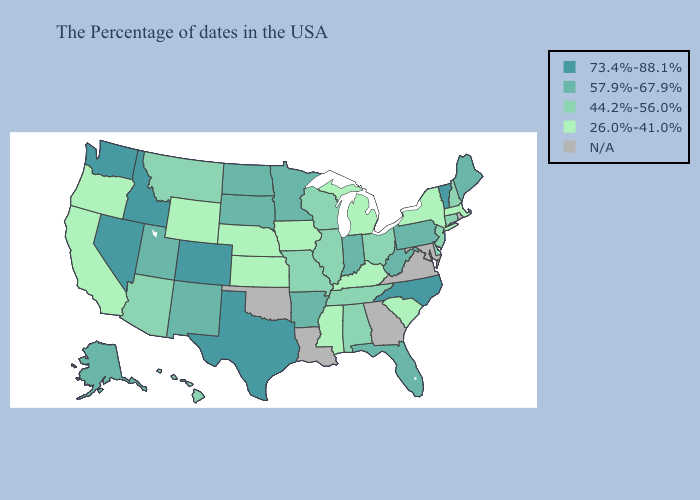Does the first symbol in the legend represent the smallest category?
Concise answer only. No. What is the lowest value in states that border Nebraska?
Give a very brief answer. 26.0%-41.0%. Does West Virginia have the highest value in the USA?
Keep it brief. No. Among the states that border Alabama , does Mississippi have the lowest value?
Concise answer only. Yes. Which states have the lowest value in the South?
Quick response, please. South Carolina, Kentucky, Mississippi. Which states have the highest value in the USA?
Write a very short answer. Vermont, North Carolina, Texas, Colorado, Idaho, Nevada, Washington. What is the value of North Carolina?
Short answer required. 73.4%-88.1%. Name the states that have a value in the range 57.9%-67.9%?
Be succinct. Maine, Pennsylvania, West Virginia, Florida, Indiana, Arkansas, Minnesota, South Dakota, North Dakota, New Mexico, Utah, Alaska. Does Oregon have the lowest value in the West?
Write a very short answer. Yes. What is the value of Nebraska?
Short answer required. 26.0%-41.0%. What is the highest value in the Northeast ?
Write a very short answer. 73.4%-88.1%. Which states hav the highest value in the MidWest?
Keep it brief. Indiana, Minnesota, South Dakota, North Dakota. What is the value of North Dakota?
Quick response, please. 57.9%-67.9%. 